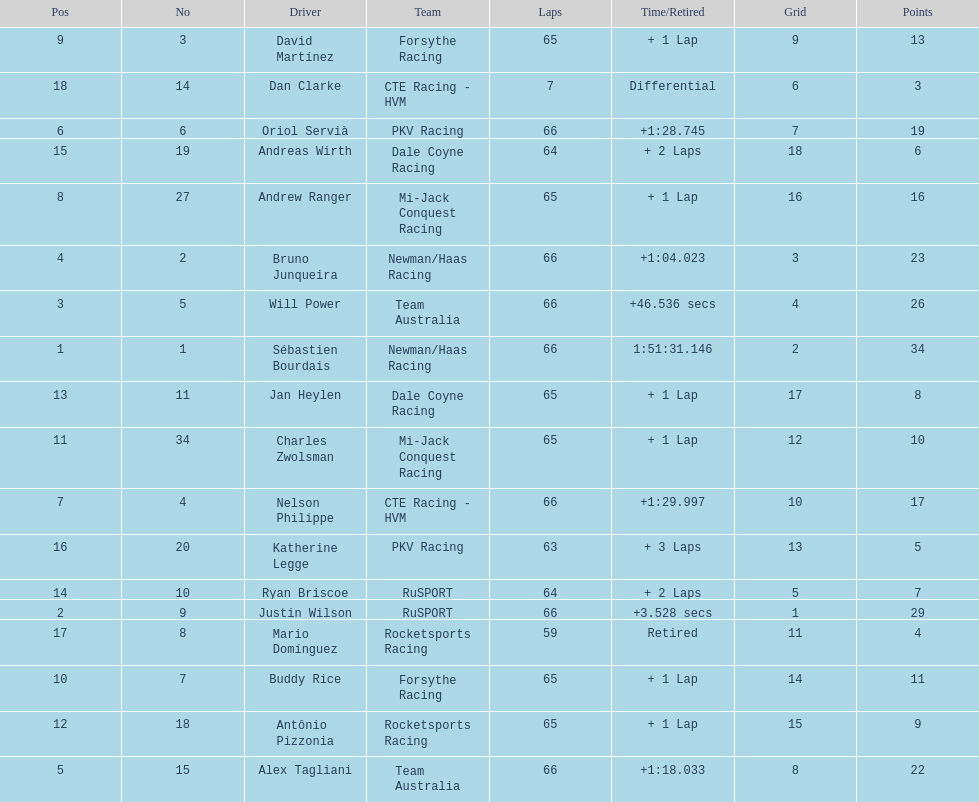At the 2006 gran premio telmex, who finished last? Dan Clarke. 